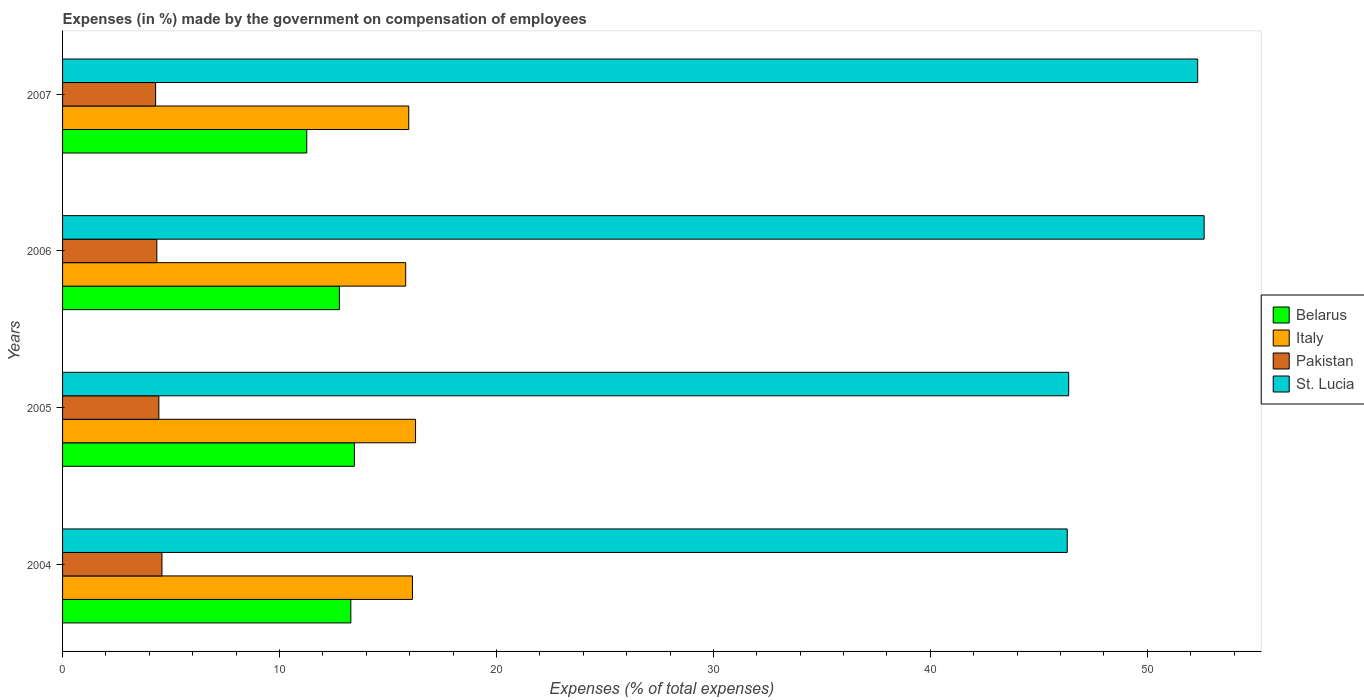Are the number of bars on each tick of the Y-axis equal?
Make the answer very short. Yes. How many bars are there on the 1st tick from the top?
Offer a very short reply. 4. In how many cases, is the number of bars for a given year not equal to the number of legend labels?
Keep it short and to the point. 0. What is the percentage of expenses made by the government on compensation of employees in Italy in 2005?
Keep it short and to the point. 16.27. Across all years, what is the maximum percentage of expenses made by the government on compensation of employees in Belarus?
Keep it short and to the point. 13.45. Across all years, what is the minimum percentage of expenses made by the government on compensation of employees in St. Lucia?
Your answer should be very brief. 46.31. In which year was the percentage of expenses made by the government on compensation of employees in Italy minimum?
Provide a succinct answer. 2006. What is the total percentage of expenses made by the government on compensation of employees in Italy in the graph?
Give a very brief answer. 64.17. What is the difference between the percentage of expenses made by the government on compensation of employees in St. Lucia in 2005 and that in 2007?
Give a very brief answer. -5.95. What is the difference between the percentage of expenses made by the government on compensation of employees in Pakistan in 2005 and the percentage of expenses made by the government on compensation of employees in St. Lucia in 2007?
Offer a very short reply. -47.88. What is the average percentage of expenses made by the government on compensation of employees in Pakistan per year?
Your answer should be very brief. 4.41. In the year 2007, what is the difference between the percentage of expenses made by the government on compensation of employees in Pakistan and percentage of expenses made by the government on compensation of employees in St. Lucia?
Keep it short and to the point. -48.03. What is the ratio of the percentage of expenses made by the government on compensation of employees in Belarus in 2004 to that in 2006?
Give a very brief answer. 1.04. Is the percentage of expenses made by the government on compensation of employees in St. Lucia in 2004 less than that in 2005?
Your response must be concise. Yes. What is the difference between the highest and the second highest percentage of expenses made by the government on compensation of employees in Pakistan?
Provide a short and direct response. 0.14. What is the difference between the highest and the lowest percentage of expenses made by the government on compensation of employees in Belarus?
Provide a short and direct response. 2.19. What does the 4th bar from the bottom in 2005 represents?
Provide a short and direct response. St. Lucia. How many bars are there?
Ensure brevity in your answer.  16. Are all the bars in the graph horizontal?
Your response must be concise. Yes. How many years are there in the graph?
Make the answer very short. 4. Does the graph contain any zero values?
Offer a terse response. No. What is the title of the graph?
Make the answer very short. Expenses (in %) made by the government on compensation of employees. Does "High income: OECD" appear as one of the legend labels in the graph?
Ensure brevity in your answer.  No. What is the label or title of the X-axis?
Your answer should be compact. Expenses (% of total expenses). What is the Expenses (% of total expenses) of Belarus in 2004?
Offer a very short reply. 13.29. What is the Expenses (% of total expenses) in Italy in 2004?
Provide a short and direct response. 16.13. What is the Expenses (% of total expenses) in Pakistan in 2004?
Make the answer very short. 4.58. What is the Expenses (% of total expenses) of St. Lucia in 2004?
Provide a succinct answer. 46.31. What is the Expenses (% of total expenses) of Belarus in 2005?
Your response must be concise. 13.45. What is the Expenses (% of total expenses) of Italy in 2005?
Your answer should be compact. 16.27. What is the Expenses (% of total expenses) in Pakistan in 2005?
Offer a very short reply. 4.44. What is the Expenses (% of total expenses) of St. Lucia in 2005?
Your response must be concise. 46.38. What is the Expenses (% of total expenses) in Belarus in 2006?
Offer a terse response. 12.76. What is the Expenses (% of total expenses) of Italy in 2006?
Provide a succinct answer. 15.82. What is the Expenses (% of total expenses) of Pakistan in 2006?
Offer a terse response. 4.34. What is the Expenses (% of total expenses) in St. Lucia in 2006?
Offer a terse response. 52.62. What is the Expenses (% of total expenses) of Belarus in 2007?
Make the answer very short. 11.26. What is the Expenses (% of total expenses) of Italy in 2007?
Keep it short and to the point. 15.96. What is the Expenses (% of total expenses) of Pakistan in 2007?
Give a very brief answer. 4.29. What is the Expenses (% of total expenses) of St. Lucia in 2007?
Offer a very short reply. 52.32. Across all years, what is the maximum Expenses (% of total expenses) in Belarus?
Offer a very short reply. 13.45. Across all years, what is the maximum Expenses (% of total expenses) in Italy?
Make the answer very short. 16.27. Across all years, what is the maximum Expenses (% of total expenses) of Pakistan?
Your answer should be very brief. 4.58. Across all years, what is the maximum Expenses (% of total expenses) of St. Lucia?
Make the answer very short. 52.62. Across all years, what is the minimum Expenses (% of total expenses) of Belarus?
Keep it short and to the point. 11.26. Across all years, what is the minimum Expenses (% of total expenses) in Italy?
Make the answer very short. 15.82. Across all years, what is the minimum Expenses (% of total expenses) in Pakistan?
Your response must be concise. 4.29. Across all years, what is the minimum Expenses (% of total expenses) of St. Lucia?
Ensure brevity in your answer.  46.31. What is the total Expenses (% of total expenses) in Belarus in the graph?
Offer a very short reply. 50.76. What is the total Expenses (% of total expenses) of Italy in the graph?
Make the answer very short. 64.17. What is the total Expenses (% of total expenses) of Pakistan in the graph?
Give a very brief answer. 17.65. What is the total Expenses (% of total expenses) of St. Lucia in the graph?
Provide a succinct answer. 197.63. What is the difference between the Expenses (% of total expenses) of Belarus in 2004 and that in 2005?
Your answer should be very brief. -0.16. What is the difference between the Expenses (% of total expenses) of Italy in 2004 and that in 2005?
Provide a succinct answer. -0.14. What is the difference between the Expenses (% of total expenses) in Pakistan in 2004 and that in 2005?
Offer a terse response. 0.14. What is the difference between the Expenses (% of total expenses) of St. Lucia in 2004 and that in 2005?
Offer a very short reply. -0.07. What is the difference between the Expenses (% of total expenses) in Belarus in 2004 and that in 2006?
Offer a terse response. 0.53. What is the difference between the Expenses (% of total expenses) of Italy in 2004 and that in 2006?
Provide a succinct answer. 0.31. What is the difference between the Expenses (% of total expenses) in Pakistan in 2004 and that in 2006?
Your answer should be very brief. 0.24. What is the difference between the Expenses (% of total expenses) of St. Lucia in 2004 and that in 2006?
Provide a succinct answer. -6.31. What is the difference between the Expenses (% of total expenses) in Belarus in 2004 and that in 2007?
Your answer should be compact. 2.03. What is the difference between the Expenses (% of total expenses) of Italy in 2004 and that in 2007?
Your answer should be compact. 0.17. What is the difference between the Expenses (% of total expenses) of Pakistan in 2004 and that in 2007?
Give a very brief answer. 0.29. What is the difference between the Expenses (% of total expenses) in St. Lucia in 2004 and that in 2007?
Offer a terse response. -6.01. What is the difference between the Expenses (% of total expenses) in Belarus in 2005 and that in 2006?
Offer a very short reply. 0.69. What is the difference between the Expenses (% of total expenses) of Italy in 2005 and that in 2006?
Ensure brevity in your answer.  0.45. What is the difference between the Expenses (% of total expenses) of Pakistan in 2005 and that in 2006?
Keep it short and to the point. 0.09. What is the difference between the Expenses (% of total expenses) of St. Lucia in 2005 and that in 2006?
Provide a short and direct response. -6.24. What is the difference between the Expenses (% of total expenses) of Belarus in 2005 and that in 2007?
Offer a terse response. 2.19. What is the difference between the Expenses (% of total expenses) of Italy in 2005 and that in 2007?
Offer a terse response. 0.31. What is the difference between the Expenses (% of total expenses) in Pakistan in 2005 and that in 2007?
Keep it short and to the point. 0.15. What is the difference between the Expenses (% of total expenses) in St. Lucia in 2005 and that in 2007?
Your response must be concise. -5.95. What is the difference between the Expenses (% of total expenses) of Belarus in 2006 and that in 2007?
Keep it short and to the point. 1.5. What is the difference between the Expenses (% of total expenses) in Italy in 2006 and that in 2007?
Provide a succinct answer. -0.14. What is the difference between the Expenses (% of total expenses) in Pakistan in 2006 and that in 2007?
Provide a short and direct response. 0.06. What is the difference between the Expenses (% of total expenses) of St. Lucia in 2006 and that in 2007?
Your answer should be compact. 0.3. What is the difference between the Expenses (% of total expenses) in Belarus in 2004 and the Expenses (% of total expenses) in Italy in 2005?
Keep it short and to the point. -2.98. What is the difference between the Expenses (% of total expenses) of Belarus in 2004 and the Expenses (% of total expenses) of Pakistan in 2005?
Your answer should be compact. 8.85. What is the difference between the Expenses (% of total expenses) of Belarus in 2004 and the Expenses (% of total expenses) of St. Lucia in 2005?
Offer a very short reply. -33.09. What is the difference between the Expenses (% of total expenses) of Italy in 2004 and the Expenses (% of total expenses) of Pakistan in 2005?
Offer a very short reply. 11.69. What is the difference between the Expenses (% of total expenses) of Italy in 2004 and the Expenses (% of total expenses) of St. Lucia in 2005?
Make the answer very short. -30.25. What is the difference between the Expenses (% of total expenses) in Pakistan in 2004 and the Expenses (% of total expenses) in St. Lucia in 2005?
Provide a succinct answer. -41.79. What is the difference between the Expenses (% of total expenses) in Belarus in 2004 and the Expenses (% of total expenses) in Italy in 2006?
Provide a succinct answer. -2.53. What is the difference between the Expenses (% of total expenses) of Belarus in 2004 and the Expenses (% of total expenses) of Pakistan in 2006?
Give a very brief answer. 8.94. What is the difference between the Expenses (% of total expenses) of Belarus in 2004 and the Expenses (% of total expenses) of St. Lucia in 2006?
Your answer should be compact. -39.33. What is the difference between the Expenses (% of total expenses) of Italy in 2004 and the Expenses (% of total expenses) of Pakistan in 2006?
Offer a very short reply. 11.78. What is the difference between the Expenses (% of total expenses) in Italy in 2004 and the Expenses (% of total expenses) in St. Lucia in 2006?
Provide a succinct answer. -36.49. What is the difference between the Expenses (% of total expenses) of Pakistan in 2004 and the Expenses (% of total expenses) of St. Lucia in 2006?
Your answer should be very brief. -48.04. What is the difference between the Expenses (% of total expenses) of Belarus in 2004 and the Expenses (% of total expenses) of Italy in 2007?
Ensure brevity in your answer.  -2.67. What is the difference between the Expenses (% of total expenses) in Belarus in 2004 and the Expenses (% of total expenses) in Pakistan in 2007?
Make the answer very short. 9. What is the difference between the Expenses (% of total expenses) in Belarus in 2004 and the Expenses (% of total expenses) in St. Lucia in 2007?
Keep it short and to the point. -39.03. What is the difference between the Expenses (% of total expenses) of Italy in 2004 and the Expenses (% of total expenses) of Pakistan in 2007?
Your answer should be very brief. 11.84. What is the difference between the Expenses (% of total expenses) of Italy in 2004 and the Expenses (% of total expenses) of St. Lucia in 2007?
Make the answer very short. -36.19. What is the difference between the Expenses (% of total expenses) in Pakistan in 2004 and the Expenses (% of total expenses) in St. Lucia in 2007?
Make the answer very short. -47.74. What is the difference between the Expenses (% of total expenses) in Belarus in 2005 and the Expenses (% of total expenses) in Italy in 2006?
Your response must be concise. -2.37. What is the difference between the Expenses (% of total expenses) of Belarus in 2005 and the Expenses (% of total expenses) of Pakistan in 2006?
Make the answer very short. 9.11. What is the difference between the Expenses (% of total expenses) of Belarus in 2005 and the Expenses (% of total expenses) of St. Lucia in 2006?
Provide a short and direct response. -39.17. What is the difference between the Expenses (% of total expenses) in Italy in 2005 and the Expenses (% of total expenses) in Pakistan in 2006?
Offer a very short reply. 11.93. What is the difference between the Expenses (% of total expenses) of Italy in 2005 and the Expenses (% of total expenses) of St. Lucia in 2006?
Your answer should be very brief. -36.35. What is the difference between the Expenses (% of total expenses) in Pakistan in 2005 and the Expenses (% of total expenses) in St. Lucia in 2006?
Your response must be concise. -48.18. What is the difference between the Expenses (% of total expenses) in Belarus in 2005 and the Expenses (% of total expenses) in Italy in 2007?
Your response must be concise. -2.51. What is the difference between the Expenses (% of total expenses) in Belarus in 2005 and the Expenses (% of total expenses) in Pakistan in 2007?
Provide a short and direct response. 9.16. What is the difference between the Expenses (% of total expenses) of Belarus in 2005 and the Expenses (% of total expenses) of St. Lucia in 2007?
Your answer should be very brief. -38.87. What is the difference between the Expenses (% of total expenses) of Italy in 2005 and the Expenses (% of total expenses) of Pakistan in 2007?
Your answer should be very brief. 11.98. What is the difference between the Expenses (% of total expenses) of Italy in 2005 and the Expenses (% of total expenses) of St. Lucia in 2007?
Give a very brief answer. -36.05. What is the difference between the Expenses (% of total expenses) of Pakistan in 2005 and the Expenses (% of total expenses) of St. Lucia in 2007?
Keep it short and to the point. -47.88. What is the difference between the Expenses (% of total expenses) of Belarus in 2006 and the Expenses (% of total expenses) of Italy in 2007?
Your response must be concise. -3.2. What is the difference between the Expenses (% of total expenses) of Belarus in 2006 and the Expenses (% of total expenses) of Pakistan in 2007?
Your answer should be compact. 8.47. What is the difference between the Expenses (% of total expenses) of Belarus in 2006 and the Expenses (% of total expenses) of St. Lucia in 2007?
Your answer should be very brief. -39.56. What is the difference between the Expenses (% of total expenses) of Italy in 2006 and the Expenses (% of total expenses) of Pakistan in 2007?
Your answer should be very brief. 11.53. What is the difference between the Expenses (% of total expenses) in Italy in 2006 and the Expenses (% of total expenses) in St. Lucia in 2007?
Offer a very short reply. -36.51. What is the difference between the Expenses (% of total expenses) in Pakistan in 2006 and the Expenses (% of total expenses) in St. Lucia in 2007?
Your answer should be compact. -47.98. What is the average Expenses (% of total expenses) in Belarus per year?
Provide a short and direct response. 12.69. What is the average Expenses (% of total expenses) in Italy per year?
Keep it short and to the point. 16.04. What is the average Expenses (% of total expenses) of Pakistan per year?
Make the answer very short. 4.41. What is the average Expenses (% of total expenses) in St. Lucia per year?
Offer a very short reply. 49.41. In the year 2004, what is the difference between the Expenses (% of total expenses) of Belarus and Expenses (% of total expenses) of Italy?
Make the answer very short. -2.84. In the year 2004, what is the difference between the Expenses (% of total expenses) of Belarus and Expenses (% of total expenses) of Pakistan?
Ensure brevity in your answer.  8.71. In the year 2004, what is the difference between the Expenses (% of total expenses) in Belarus and Expenses (% of total expenses) in St. Lucia?
Offer a terse response. -33.02. In the year 2004, what is the difference between the Expenses (% of total expenses) of Italy and Expenses (% of total expenses) of Pakistan?
Your response must be concise. 11.55. In the year 2004, what is the difference between the Expenses (% of total expenses) of Italy and Expenses (% of total expenses) of St. Lucia?
Ensure brevity in your answer.  -30.18. In the year 2004, what is the difference between the Expenses (% of total expenses) in Pakistan and Expenses (% of total expenses) in St. Lucia?
Your answer should be very brief. -41.73. In the year 2005, what is the difference between the Expenses (% of total expenses) in Belarus and Expenses (% of total expenses) in Italy?
Provide a succinct answer. -2.82. In the year 2005, what is the difference between the Expenses (% of total expenses) in Belarus and Expenses (% of total expenses) in Pakistan?
Provide a short and direct response. 9.01. In the year 2005, what is the difference between the Expenses (% of total expenses) in Belarus and Expenses (% of total expenses) in St. Lucia?
Keep it short and to the point. -32.93. In the year 2005, what is the difference between the Expenses (% of total expenses) in Italy and Expenses (% of total expenses) in Pakistan?
Provide a short and direct response. 11.83. In the year 2005, what is the difference between the Expenses (% of total expenses) of Italy and Expenses (% of total expenses) of St. Lucia?
Your response must be concise. -30.11. In the year 2005, what is the difference between the Expenses (% of total expenses) of Pakistan and Expenses (% of total expenses) of St. Lucia?
Your answer should be very brief. -41.94. In the year 2006, what is the difference between the Expenses (% of total expenses) in Belarus and Expenses (% of total expenses) in Italy?
Your response must be concise. -3.06. In the year 2006, what is the difference between the Expenses (% of total expenses) of Belarus and Expenses (% of total expenses) of Pakistan?
Offer a very short reply. 8.42. In the year 2006, what is the difference between the Expenses (% of total expenses) in Belarus and Expenses (% of total expenses) in St. Lucia?
Your answer should be very brief. -39.86. In the year 2006, what is the difference between the Expenses (% of total expenses) of Italy and Expenses (% of total expenses) of Pakistan?
Your response must be concise. 11.47. In the year 2006, what is the difference between the Expenses (% of total expenses) in Italy and Expenses (% of total expenses) in St. Lucia?
Offer a terse response. -36.8. In the year 2006, what is the difference between the Expenses (% of total expenses) in Pakistan and Expenses (% of total expenses) in St. Lucia?
Make the answer very short. -48.27. In the year 2007, what is the difference between the Expenses (% of total expenses) of Belarus and Expenses (% of total expenses) of Italy?
Give a very brief answer. -4.7. In the year 2007, what is the difference between the Expenses (% of total expenses) of Belarus and Expenses (% of total expenses) of Pakistan?
Your response must be concise. 6.97. In the year 2007, what is the difference between the Expenses (% of total expenses) of Belarus and Expenses (% of total expenses) of St. Lucia?
Offer a terse response. -41.07. In the year 2007, what is the difference between the Expenses (% of total expenses) of Italy and Expenses (% of total expenses) of Pakistan?
Your response must be concise. 11.67. In the year 2007, what is the difference between the Expenses (% of total expenses) in Italy and Expenses (% of total expenses) in St. Lucia?
Provide a short and direct response. -36.36. In the year 2007, what is the difference between the Expenses (% of total expenses) of Pakistan and Expenses (% of total expenses) of St. Lucia?
Offer a terse response. -48.03. What is the ratio of the Expenses (% of total expenses) in Pakistan in 2004 to that in 2005?
Your response must be concise. 1.03. What is the ratio of the Expenses (% of total expenses) of St. Lucia in 2004 to that in 2005?
Your answer should be compact. 1. What is the ratio of the Expenses (% of total expenses) in Belarus in 2004 to that in 2006?
Make the answer very short. 1.04. What is the ratio of the Expenses (% of total expenses) in Italy in 2004 to that in 2006?
Provide a short and direct response. 1.02. What is the ratio of the Expenses (% of total expenses) of Pakistan in 2004 to that in 2006?
Your answer should be very brief. 1.05. What is the ratio of the Expenses (% of total expenses) in St. Lucia in 2004 to that in 2006?
Your response must be concise. 0.88. What is the ratio of the Expenses (% of total expenses) in Belarus in 2004 to that in 2007?
Provide a short and direct response. 1.18. What is the ratio of the Expenses (% of total expenses) in Italy in 2004 to that in 2007?
Ensure brevity in your answer.  1.01. What is the ratio of the Expenses (% of total expenses) in Pakistan in 2004 to that in 2007?
Make the answer very short. 1.07. What is the ratio of the Expenses (% of total expenses) in St. Lucia in 2004 to that in 2007?
Offer a terse response. 0.89. What is the ratio of the Expenses (% of total expenses) of Belarus in 2005 to that in 2006?
Provide a short and direct response. 1.05. What is the ratio of the Expenses (% of total expenses) of Italy in 2005 to that in 2006?
Your answer should be very brief. 1.03. What is the ratio of the Expenses (% of total expenses) of Pakistan in 2005 to that in 2006?
Offer a very short reply. 1.02. What is the ratio of the Expenses (% of total expenses) in St. Lucia in 2005 to that in 2006?
Keep it short and to the point. 0.88. What is the ratio of the Expenses (% of total expenses) of Belarus in 2005 to that in 2007?
Provide a short and direct response. 1.2. What is the ratio of the Expenses (% of total expenses) of Italy in 2005 to that in 2007?
Make the answer very short. 1.02. What is the ratio of the Expenses (% of total expenses) of Pakistan in 2005 to that in 2007?
Your answer should be very brief. 1.03. What is the ratio of the Expenses (% of total expenses) of St. Lucia in 2005 to that in 2007?
Your answer should be compact. 0.89. What is the ratio of the Expenses (% of total expenses) of Belarus in 2006 to that in 2007?
Your answer should be very brief. 1.13. What is the ratio of the Expenses (% of total expenses) in St. Lucia in 2006 to that in 2007?
Make the answer very short. 1.01. What is the difference between the highest and the second highest Expenses (% of total expenses) in Belarus?
Offer a terse response. 0.16. What is the difference between the highest and the second highest Expenses (% of total expenses) of Italy?
Ensure brevity in your answer.  0.14. What is the difference between the highest and the second highest Expenses (% of total expenses) of Pakistan?
Your answer should be compact. 0.14. What is the difference between the highest and the second highest Expenses (% of total expenses) of St. Lucia?
Offer a very short reply. 0.3. What is the difference between the highest and the lowest Expenses (% of total expenses) in Belarus?
Offer a very short reply. 2.19. What is the difference between the highest and the lowest Expenses (% of total expenses) of Italy?
Offer a very short reply. 0.45. What is the difference between the highest and the lowest Expenses (% of total expenses) of Pakistan?
Provide a short and direct response. 0.29. What is the difference between the highest and the lowest Expenses (% of total expenses) in St. Lucia?
Provide a succinct answer. 6.31. 